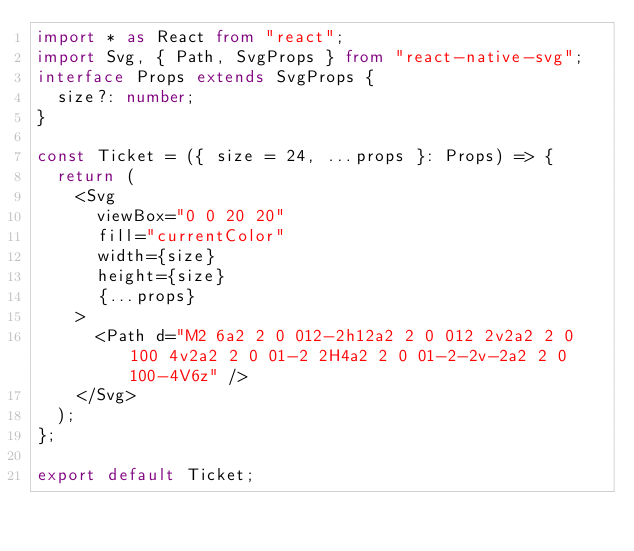Convert code to text. <code><loc_0><loc_0><loc_500><loc_500><_TypeScript_>import * as React from "react";
import Svg, { Path, SvgProps } from "react-native-svg";
interface Props extends SvgProps {
  size?: number;
}

const Ticket = ({ size = 24, ...props }: Props) => {
  return (
    <Svg
      viewBox="0 0 20 20"
      fill="currentColor"
      width={size}
      height={size}
      {...props}
    >
      <Path d="M2 6a2 2 0 012-2h12a2 2 0 012 2v2a2 2 0 100 4v2a2 2 0 01-2 2H4a2 2 0 01-2-2v-2a2 2 0 100-4V6z" />
    </Svg>
  );
};

export default Ticket;
</code> 